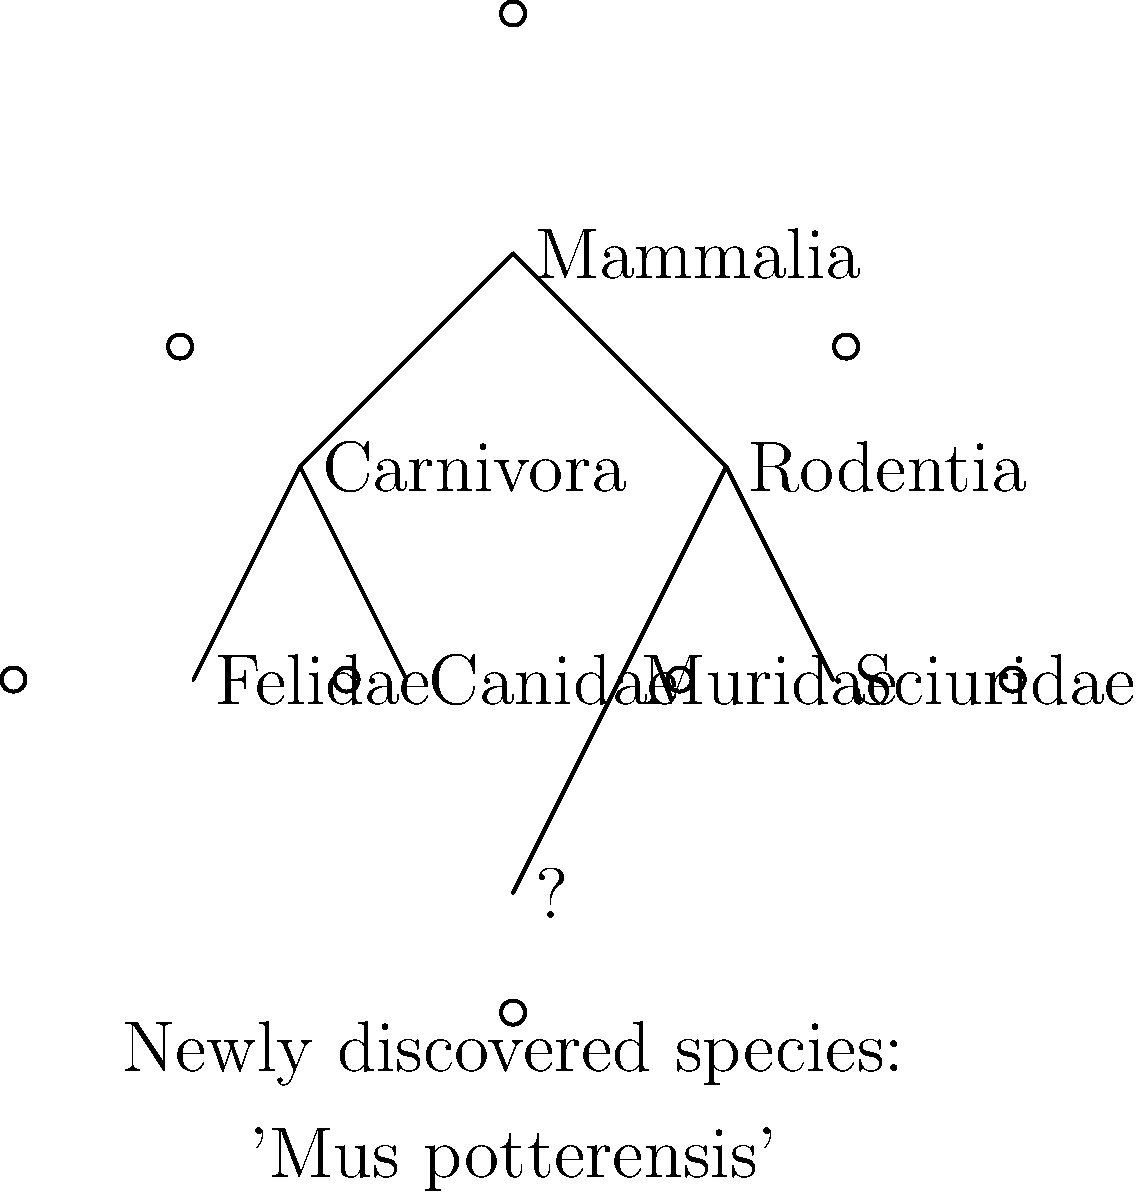A new species of rodent has been discovered and named 'Mus potterensis' in honor of the Harry Potter book series. Based on its genus name and the phylogenetic tree shown, where should this species be placed? To determine the correct placement of 'Mus potterensis' in the phylogenetic tree, we need to follow these steps:

1. Identify the genus: The genus name 'Mus' is the first part of the species name 'Mus potterensis'.

2. Locate the relevant taxonomic groups in the tree:
   - Mammalia (top level)
   - Rodentia (one of two main branches under Mammalia)
   - Muridae and Sciuridae (two families under Rodentia)

3. Consider the genus 'Mus':
   - 'Mus' is the genus that includes mice.
   - Mice belong to the family Muridae.

4. Analyze the tree structure:
   - The question mark (?) is connected to the Rodentia branch.
   - Under Rodentia, we have Muridae and Sciuridae.

5. Make the connection:
   - Since 'Mus potterensis' is a species of 'Mus', and 'Mus' belongs to Muridae, the new species should be placed in the Muridae branch.

6. Conclude:
   The correct placement for 'Mus potterensis' is under the Muridae branch, which is represented by the question mark (?) in the phylogenetic tree.

This placement reflects both the scientific classification (based on the genus 'Mus') and the whimsical nature of naming species after pop culture references (in this case, Harry Potter).
Answer: Muridae 